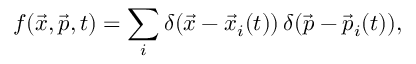Convert formula to latex. <formula><loc_0><loc_0><loc_500><loc_500>f ( \vec { x } , \vec { p } , t ) = \sum _ { i } \delta ( \vec { x } - { \vec { x } } _ { i } ( t ) ) \, \delta ( \vec { p } - { \vec { p } } _ { i } ( t ) ) ,</formula> 